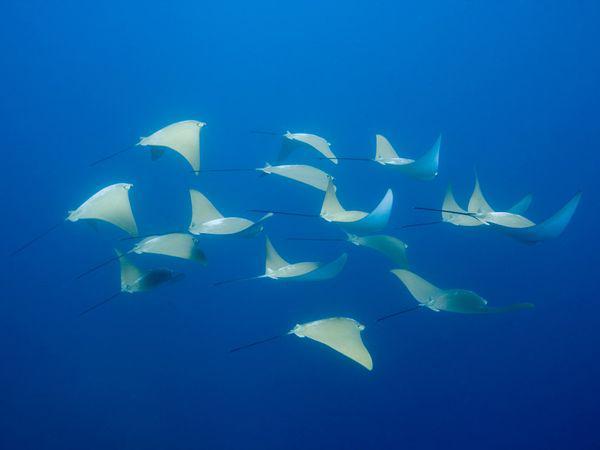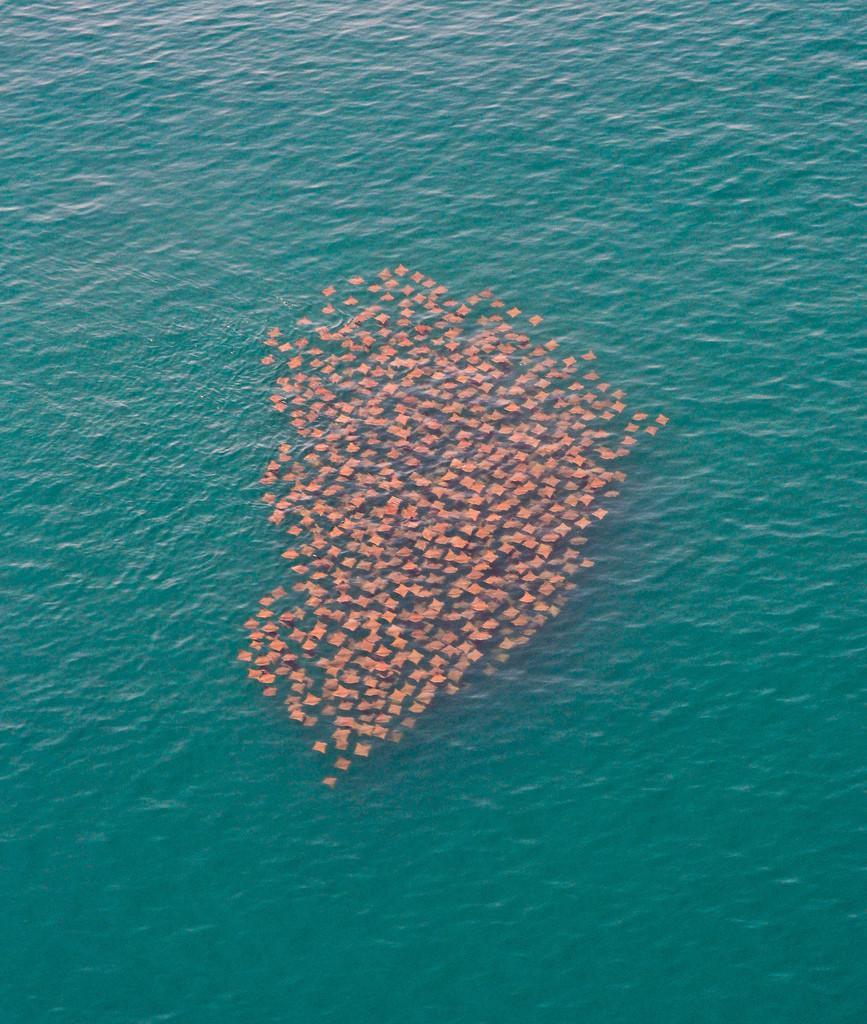The first image is the image on the left, the second image is the image on the right. For the images shown, is this caption "There is a group of stingrays in the water." true? Answer yes or no. Yes. The first image is the image on the left, the second image is the image on the right. Assess this claim about the two images: "There is one spotted eagle ray.". Correct or not? Answer yes or no. No. 